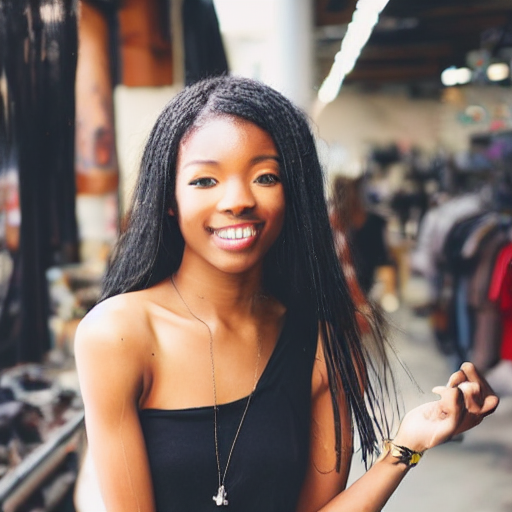Can you tell what kind of environment the subject is in? The subject appears to be in a casual, urban commercial area. There are clothing racks and possibly a variety of stores in the background, suggesting that this might be an open-air market or a boutique shopping district. 